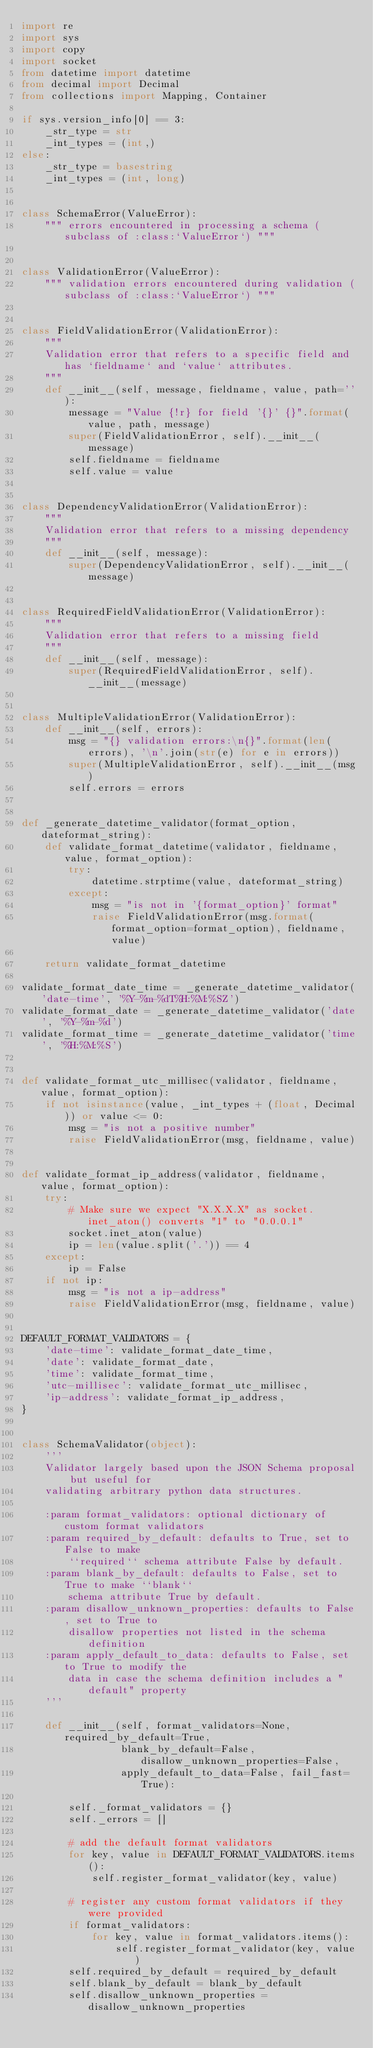<code> <loc_0><loc_0><loc_500><loc_500><_Python_>import re
import sys
import copy
import socket
from datetime import datetime
from decimal import Decimal
from collections import Mapping, Container

if sys.version_info[0] == 3:
    _str_type = str
    _int_types = (int,)
else:
    _str_type = basestring
    _int_types = (int, long)


class SchemaError(ValueError):
    """ errors encountered in processing a schema (subclass of :class:`ValueError`) """


class ValidationError(ValueError):
    """ validation errors encountered during validation (subclass of :class:`ValueError`) """


class FieldValidationError(ValidationError):
    """
    Validation error that refers to a specific field and has `fieldname` and `value` attributes.
    """
    def __init__(self, message, fieldname, value, path=''):
        message = "Value {!r} for field '{}' {}".format(value, path, message)
        super(FieldValidationError, self).__init__(message)
        self.fieldname = fieldname
        self.value = value


class DependencyValidationError(ValidationError):
    """
    Validation error that refers to a missing dependency
    """
    def __init__(self, message):
        super(DependencyValidationError, self).__init__(message)


class RequiredFieldValidationError(ValidationError):
    """
    Validation error that refers to a missing field
    """
    def __init__(self, message):
        super(RequiredFieldValidationError, self).__init__(message)


class MultipleValidationError(ValidationError):
    def __init__(self, errors):
        msg = "{} validation errors:\n{}".format(len(errors), '\n'.join(str(e) for e in errors))
        super(MultipleValidationError, self).__init__(msg)
        self.errors = errors


def _generate_datetime_validator(format_option, dateformat_string):
    def validate_format_datetime(validator, fieldname, value, format_option):
        try:
            datetime.strptime(value, dateformat_string)
        except:
            msg = "is not in '{format_option}' format"
            raise FieldValidationError(msg.format(format_option=format_option), fieldname, value)

    return validate_format_datetime

validate_format_date_time = _generate_datetime_validator('date-time', '%Y-%m-%dT%H:%M:%SZ')
validate_format_date = _generate_datetime_validator('date', '%Y-%m-%d')
validate_format_time = _generate_datetime_validator('time', '%H:%M:%S')


def validate_format_utc_millisec(validator, fieldname, value, format_option):
    if not isinstance(value, _int_types + (float, Decimal)) or value <= 0:
        msg = "is not a positive number"
        raise FieldValidationError(msg, fieldname, value)


def validate_format_ip_address(validator, fieldname, value, format_option):
    try:
        # Make sure we expect "X.X.X.X" as socket.inet_aton() converts "1" to "0.0.0.1"
        socket.inet_aton(value)
        ip = len(value.split('.')) == 4
    except:
        ip = False
    if not ip:
        msg = "is not a ip-address"
        raise FieldValidationError(msg, fieldname, value)


DEFAULT_FORMAT_VALIDATORS = {
    'date-time': validate_format_date_time,
    'date': validate_format_date,
    'time': validate_format_time,
    'utc-millisec': validate_format_utc_millisec,
    'ip-address': validate_format_ip_address,
}


class SchemaValidator(object):
    '''
    Validator largely based upon the JSON Schema proposal but useful for
    validating arbitrary python data structures.

    :param format_validators: optional dictionary of custom format validators
    :param required_by_default: defaults to True, set to False to make
        ``required`` schema attribute False by default.
    :param blank_by_default: defaults to False, set to True to make ``blank``
        schema attribute True by default.
    :param disallow_unknown_properties: defaults to False, set to True to
        disallow properties not listed in the schema definition
    :param apply_default_to_data: defaults to False, set to True to modify the
        data in case the schema definition includes a "default" property
    '''

    def __init__(self, format_validators=None, required_by_default=True,
                 blank_by_default=False, disallow_unknown_properties=False,
                 apply_default_to_data=False, fail_fast=True):

        self._format_validators = {}
        self._errors = []

        # add the default format validators
        for key, value in DEFAULT_FORMAT_VALIDATORS.items():
            self.register_format_validator(key, value)

        # register any custom format validators if they were provided
        if format_validators:
            for key, value in format_validators.items():
                self.register_format_validator(key, value)
        self.required_by_default = required_by_default
        self.blank_by_default = blank_by_default
        self.disallow_unknown_properties = disallow_unknown_properties</code> 